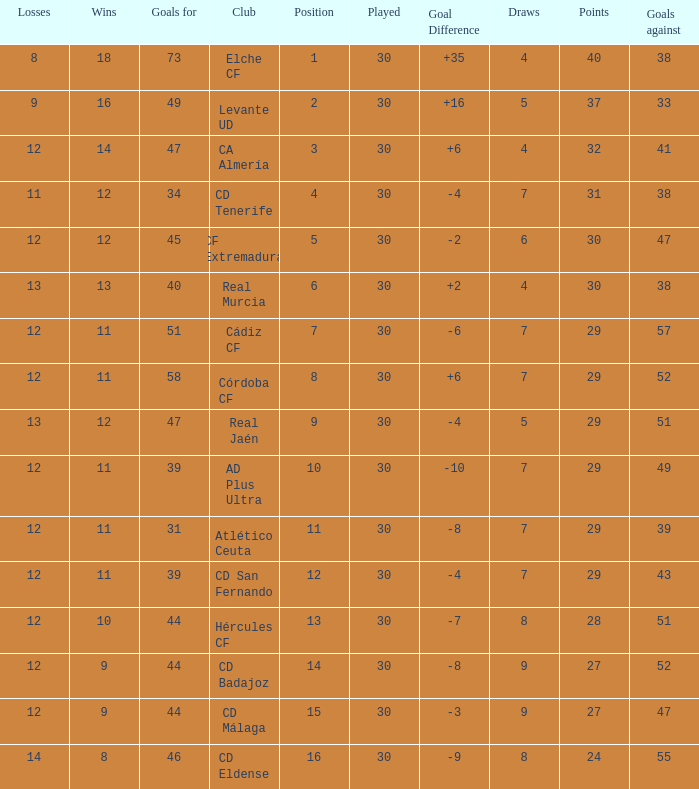What is the number of goals with less than 14 wins and a goal difference less than -4? 51, 39, 31, 44, 44, 46. Would you mind parsing the complete table? {'header': ['Losses', 'Wins', 'Goals for', 'Club', 'Position', 'Played', 'Goal Difference', 'Draws', 'Points', 'Goals against'], 'rows': [['8', '18', '73', 'Elche CF', '1', '30', '+35', '4', '40', '38'], ['9', '16', '49', 'Levante UD', '2', '30', '+16', '5', '37', '33'], ['12', '14', '47', 'CA Almería', '3', '30', '+6', '4', '32', '41'], ['11', '12', '34', 'CD Tenerife', '4', '30', '-4', '7', '31', '38'], ['12', '12', '45', 'CF Extremadura', '5', '30', '-2', '6', '30', '47'], ['13', '13', '40', 'Real Murcia', '6', '30', '+2', '4', '30', '38'], ['12', '11', '51', 'Cádiz CF', '7', '30', '-6', '7', '29', '57'], ['12', '11', '58', 'Córdoba CF', '8', '30', '+6', '7', '29', '52'], ['13', '12', '47', 'Real Jaén', '9', '30', '-4', '5', '29', '51'], ['12', '11', '39', 'AD Plus Ultra', '10', '30', '-10', '7', '29', '49'], ['12', '11', '31', 'Atlético Ceuta', '11', '30', '-8', '7', '29', '39'], ['12', '11', '39', 'CD San Fernando', '12', '30', '-4', '7', '29', '43'], ['12', '10', '44', 'Hércules CF', '13', '30', '-7', '8', '28', '51'], ['12', '9', '44', 'CD Badajoz', '14', '30', '-8', '9', '27', '52'], ['12', '9', '44', 'CD Málaga', '15', '30', '-3', '9', '27', '47'], ['14', '8', '46', 'CD Eldense', '16', '30', '-9', '8', '24', '55']]} 